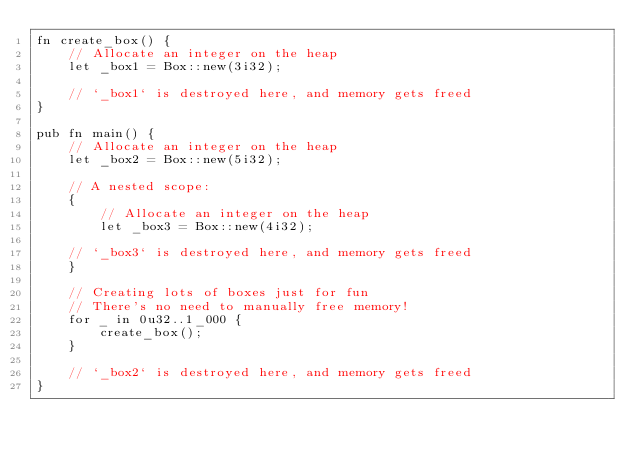<code> <loc_0><loc_0><loc_500><loc_500><_Rust_>fn create_box() {
    // Allocate an integer on the heap
    let _box1 = Box::new(3i32);

    // `_box1` is destroyed here, and memory gets freed
}

pub fn main() {
    // Allocate an integer on the heap
    let _box2 = Box::new(5i32);

    // A nested scope:
    {
        // Allocate an integer on the heap
        let _box3 = Box::new(4i32);

    // `_box3` is destroyed here, and memory gets freed
    }

    // Creating lots of boxes just for fun
    // There's no need to manually free memory!
    for _ in 0u32..1_000 {
        create_box();
    }

    // `_box2` is destroyed here, and memory gets freed
}</code> 